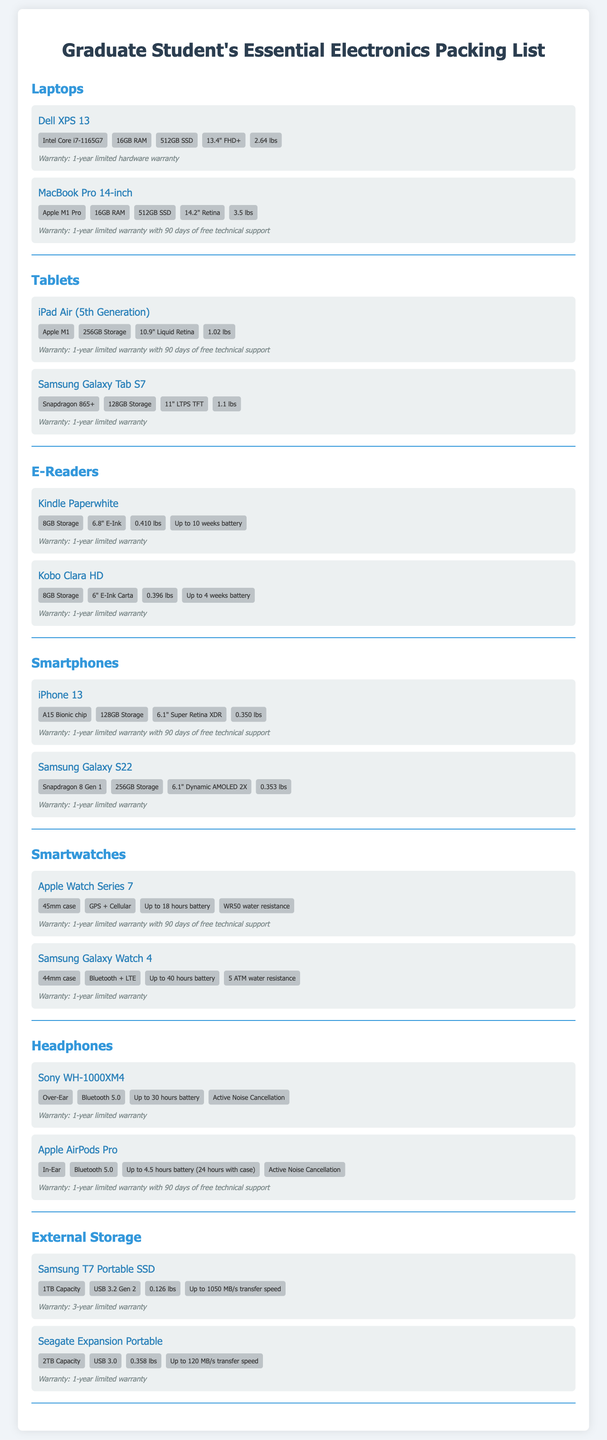What is the weight of the Dell XPS 13? The weight of the Dell XPS 13 is provided as a specific attribute in the document.
Answer: 2.64 lbs What is the storage capacity of the iPad Air (5th Generation)? The storage capacity for the iPad Air is mentioned in its specifications.
Answer: 256GB Storage Which laptop has an Apple M1 Pro chip? The specific laptop model with an Apple M1 Pro chip is highlighted in the document.
Answer: MacBook Pro 14-inch What is the warranty period for the Samsung Galaxy Tab S7? The warranty information is clearly stated for each item in the document.
Answer: 1-year limited warranty How long is the battery life of the Apple Watch Series 7? The battery life specification is included in the details of the Apple Watch Series 7.
Answer: Up to 18 hours battery Which headphone model includes Active Noise Cancellation? Active Noise Cancellation is mentioned as a feature for the headphones in the document.
Answer: Sony WH-1000XM4 What is the capacity of the Seagate Expansion Portable? The capacity information for the Seagate Expansion Portable is specifically listed.
Answer: 2TB Capacity How many different brands of smartphones are listed? The document provides a summary of smartphone brands, allowing for a count.
Answer: 2 brands What type of external storage is the Samsung T7? The type of external storage for the Samsung T7 is categorized within the document.
Answer: Portable SSD 